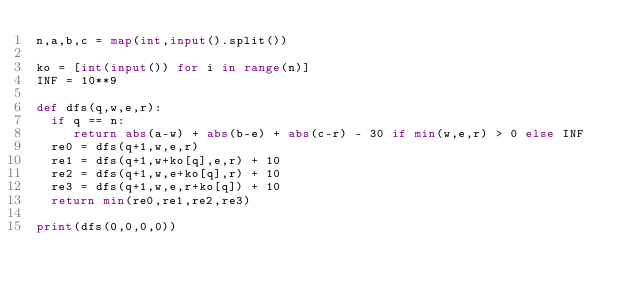<code> <loc_0><loc_0><loc_500><loc_500><_Python_>n,a,b,c = map(int,input().split())

ko = [int(input()) for i in range(n)]
INF = 10**9

def dfs(q,w,e,r):
 	if q == n:
 		 return abs(a-w) + abs(b-e) + abs(c-r) - 30 if min(w,e,r) > 0 else INF
 	re0 = dfs(q+1,w,e,r)
 	re1 = dfs(q+1,w+ko[q],e,r) + 10
 	re2 = dfs(q+1,w,e+ko[q],r) + 10
 	re3 = dfs(q+1,w,e,r+ko[q]) + 10
 	return min(re0,re1,re2,re3)

print(dfs(0,0,0,0))
</code> 